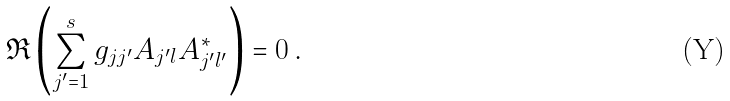<formula> <loc_0><loc_0><loc_500><loc_500>\Re \left ( \sum _ { j ^ { \prime } = 1 } ^ { s } g _ { j j ^ { \prime } } A _ { j ^ { \prime } l } A ^ { \ast } _ { j ^ { \prime } l ^ { \prime } } \right ) = 0 \, .</formula> 